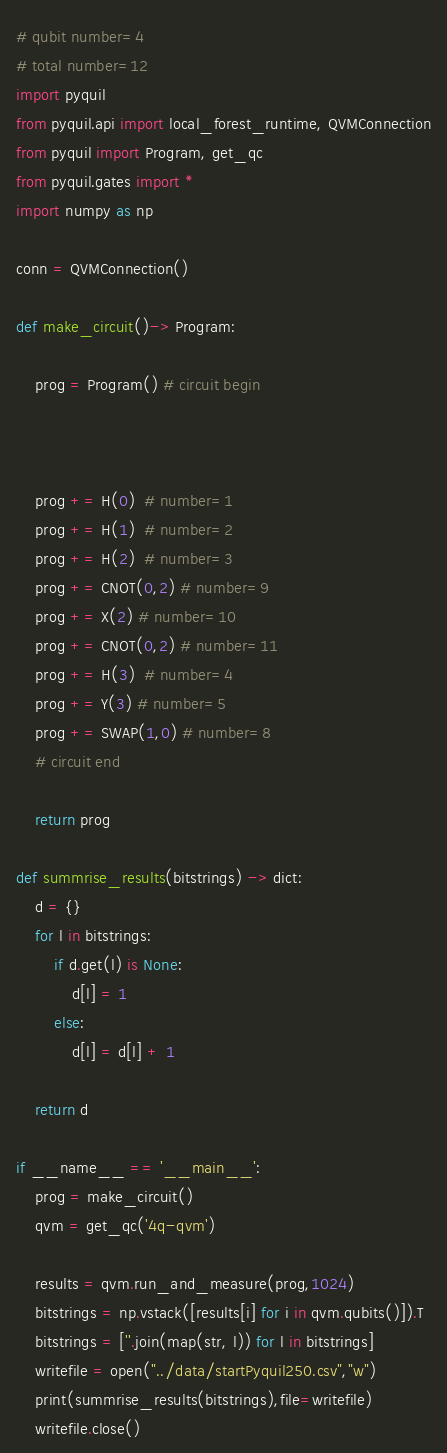<code> <loc_0><loc_0><loc_500><loc_500><_Python_># qubit number=4
# total number=12
import pyquil
from pyquil.api import local_forest_runtime, QVMConnection
from pyquil import Program, get_qc
from pyquil.gates import *
import numpy as np

conn = QVMConnection()

def make_circuit()-> Program:

    prog = Program() # circuit begin



    prog += H(0)  # number=1
    prog += H(1)  # number=2
    prog += H(2)  # number=3
    prog += CNOT(0,2) # number=9
    prog += X(2) # number=10
    prog += CNOT(0,2) # number=11
    prog += H(3)  # number=4
    prog += Y(3) # number=5
    prog += SWAP(1,0) # number=8
    # circuit end

    return prog

def summrise_results(bitstrings) -> dict:
    d = {}
    for l in bitstrings:
        if d.get(l) is None:
            d[l] = 1
        else:
            d[l] = d[l] + 1

    return d

if __name__ == '__main__':
    prog = make_circuit()
    qvm = get_qc('4q-qvm')

    results = qvm.run_and_measure(prog,1024)
    bitstrings = np.vstack([results[i] for i in qvm.qubits()]).T
    bitstrings = [''.join(map(str, l)) for l in bitstrings]
    writefile = open("../data/startPyquil250.csv","w")
    print(summrise_results(bitstrings),file=writefile)
    writefile.close()

</code> 